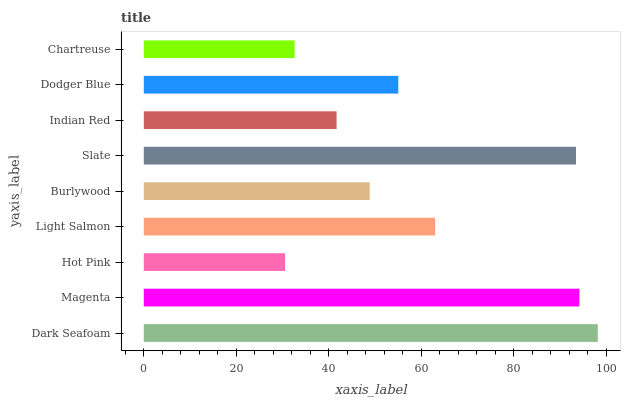Is Hot Pink the minimum?
Answer yes or no. Yes. Is Dark Seafoam the maximum?
Answer yes or no. Yes. Is Magenta the minimum?
Answer yes or no. No. Is Magenta the maximum?
Answer yes or no. No. Is Dark Seafoam greater than Magenta?
Answer yes or no. Yes. Is Magenta less than Dark Seafoam?
Answer yes or no. Yes. Is Magenta greater than Dark Seafoam?
Answer yes or no. No. Is Dark Seafoam less than Magenta?
Answer yes or no. No. Is Dodger Blue the high median?
Answer yes or no. Yes. Is Dodger Blue the low median?
Answer yes or no. Yes. Is Burlywood the high median?
Answer yes or no. No. Is Light Salmon the low median?
Answer yes or no. No. 